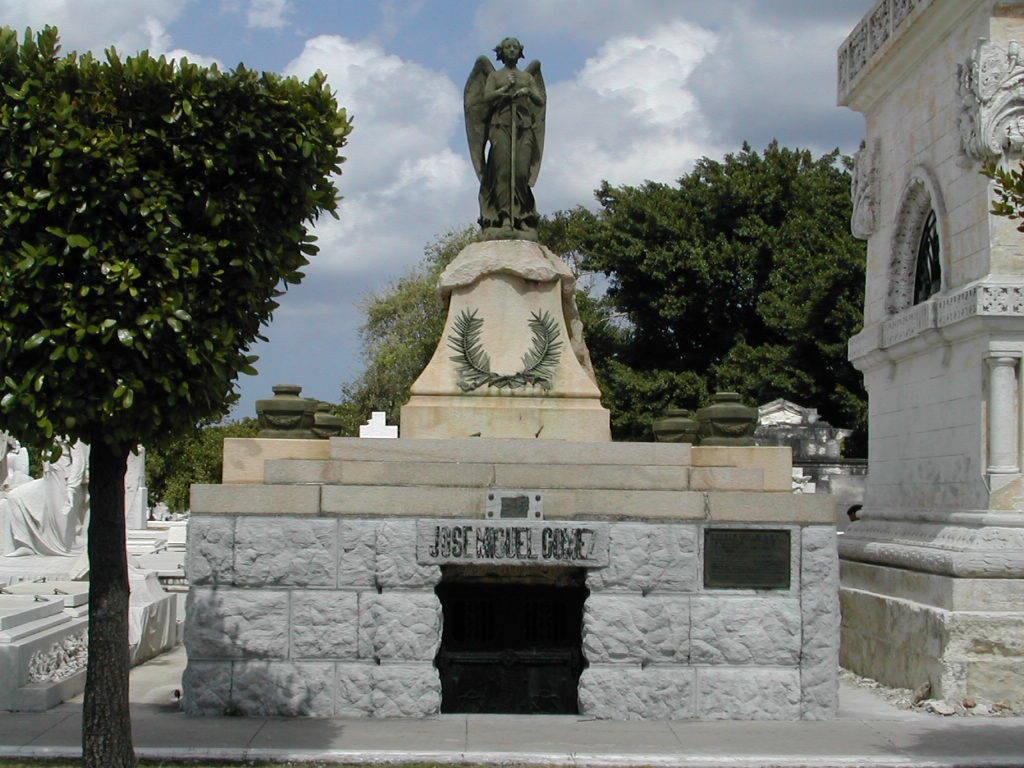What is the main subject of the image? There is a sculpture on rock bricks in the image. What type of structure is visible in the image? There is a historical building wall in the image. What can be seen in the background of the image? Trees and the sky are visible in the background of the image. What is the condition of the sky in the image? Clouds are present in the sky. What type of pie is being served on the sculpture in the image? There is no pie present in the image; it features a sculpture on rock bricks and a historical building wall. What idea does the sculpture represent in the image? The image does not provide any information about the meaning or idea behind the sculpture. 